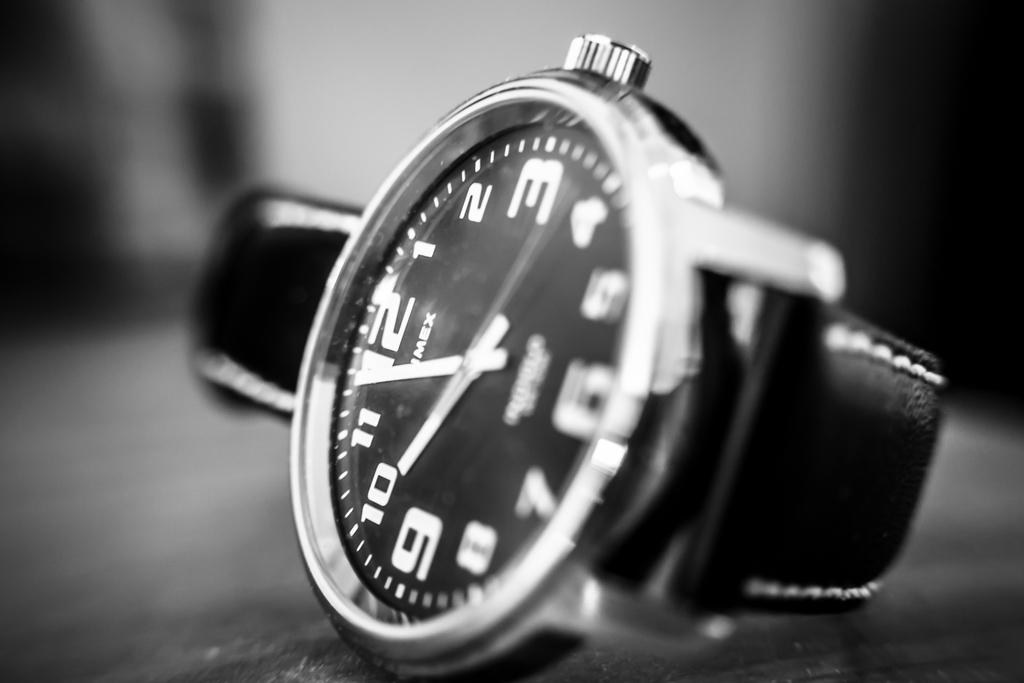What is the color scheme of the image? The image is black and white. What is the main subject of the image? There is a watch in the center of the image. Can you describe the background of the image? The background of the image is blurred. How many goldfish are swimming in the background of the image? There are no goldfish present in the image, as it is a black and white image with a blurred background. 